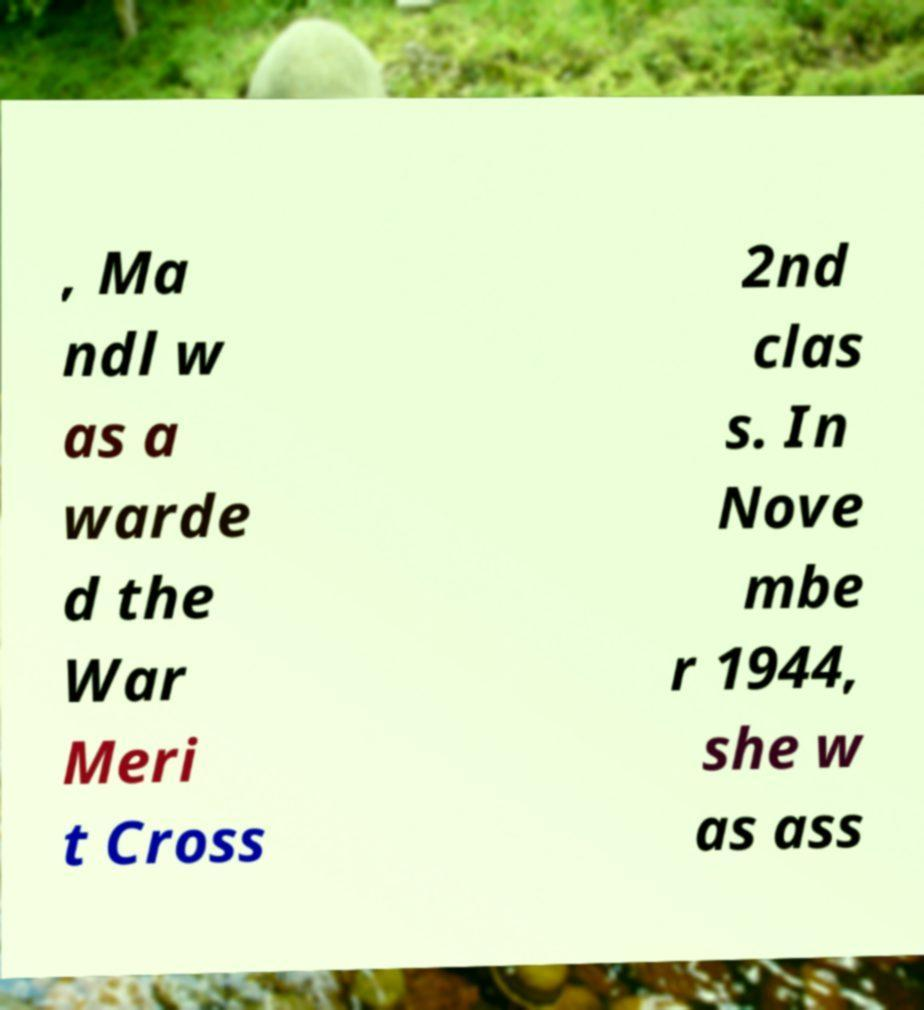Can you accurately transcribe the text from the provided image for me? , Ma ndl w as a warde d the War Meri t Cross 2nd clas s. In Nove mbe r 1944, she w as ass 